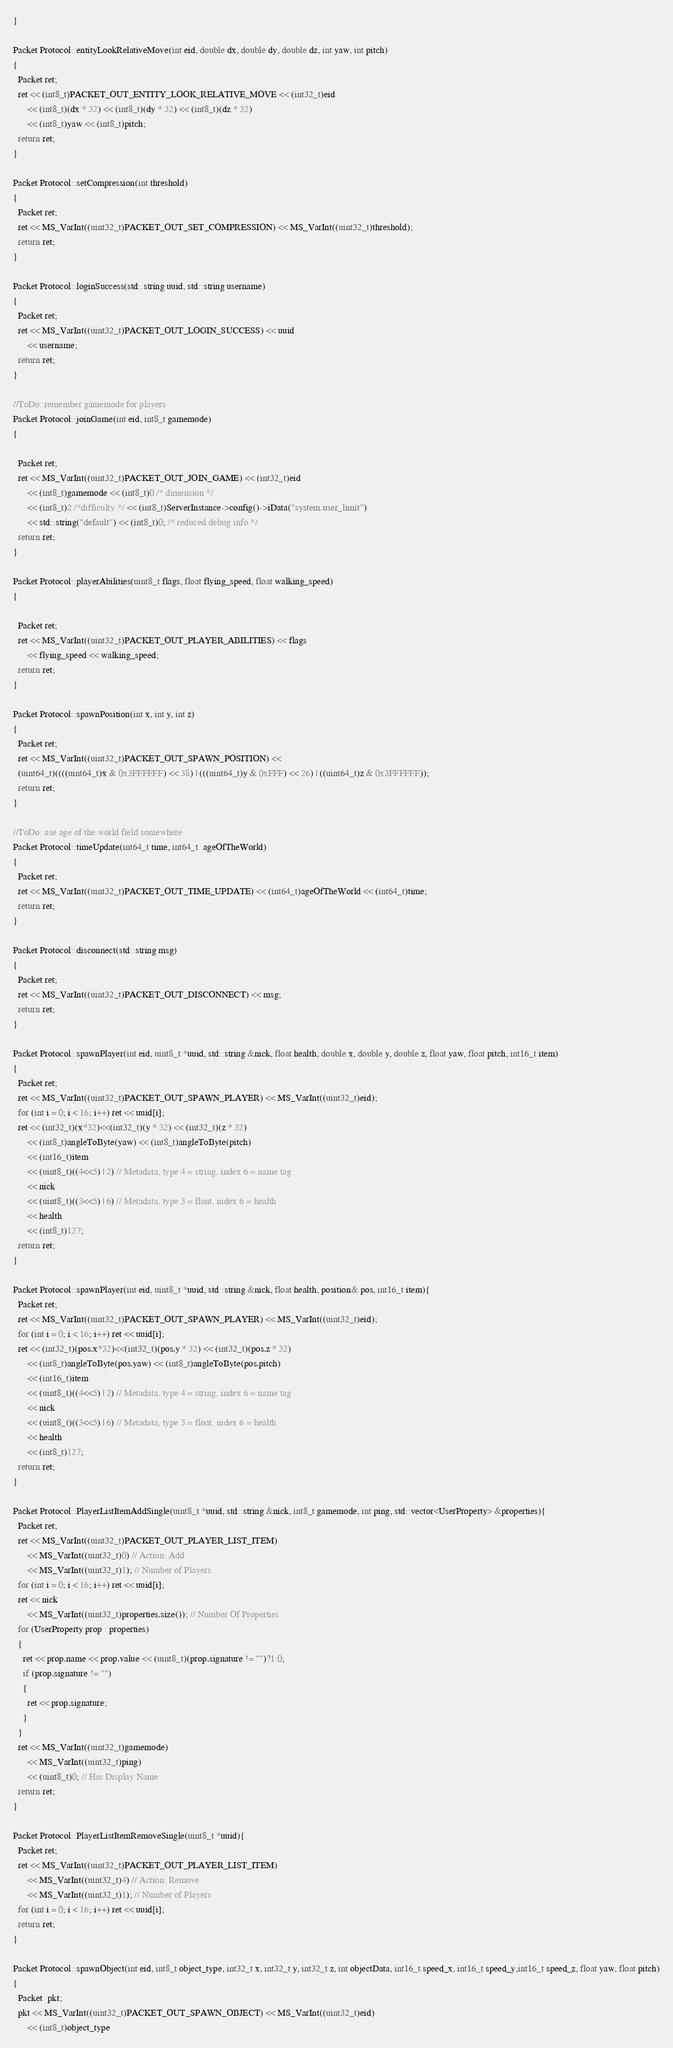Convert code to text. <code><loc_0><loc_0><loc_500><loc_500><_C++_>}
    
Packet Protocol::entityLookRelativeMove(int eid, double dx, double dy, double dz, int yaw, int pitch)
{
  Packet ret;
  ret << (int8_t)PACKET_OUT_ENTITY_LOOK_RELATIVE_MOVE << (int32_t)eid
      << (int8_t)(dx * 32) << (int8_t)(dy * 32) << (int8_t)(dz * 32)
      << (int8_t)yaw << (int8_t)pitch;
  return ret;
}

Packet Protocol::setCompression(int threshold)
{
  Packet ret;
  ret << MS_VarInt((uint32_t)PACKET_OUT_SET_COMPRESSION) << MS_VarInt((uint32_t)threshold);
  return ret;
}

Packet Protocol::loginSuccess(std::string uuid, std::string username)
{
  Packet ret;
  ret << MS_VarInt((uint32_t)PACKET_OUT_LOGIN_SUCCESS) << uuid
      << username;
  return ret;
}

//ToDo: remember gamemode for players
Packet Protocol::joinGame(int eid, int8_t gamemode)
{

  Packet ret;
  ret << MS_VarInt((uint32_t)PACKET_OUT_JOIN_GAME) << (int32_t)eid
      << (int8_t)gamemode << (int8_t)0 /* dimension */
      << (int8_t)2 /*difficulty */ << (int8_t)ServerInstance->config()->iData("system.user_limit")
      << std::string("default") << (int8_t)0; /* reduced debug info */
  return ret;
}

Packet Protocol::playerAbilities(uint8_t flags, float flying_speed, float walking_speed)
{

  Packet ret;
  ret << MS_VarInt((uint32_t)PACKET_OUT_PLAYER_ABILITIES) << flags
      << flying_speed << walking_speed;
  return ret;
}

Packet Protocol::spawnPosition(int x, int y, int z)
{
  Packet ret;
  ret << MS_VarInt((uint32_t)PACKET_OUT_SPAWN_POSITION) << 
  (uint64_t)((((uint64_t)x & 0x3FFFFFF) << 38) | (((uint64_t)y & 0xFFF) << 26) | ((uint64_t)z & 0x3FFFFFF));
  return ret;
}

//ToDo: use age of the world field somewhere
Packet Protocol::timeUpdate(int64_t time, int64_t  ageOfTheWorld)
{
  Packet ret;
  ret << MS_VarInt((uint32_t)PACKET_OUT_TIME_UPDATE) << (int64_t)ageOfTheWorld << (int64_t)time;
  return ret;
}

Packet Protocol::disconnect(std::string msg)
{
  Packet ret;
  ret << MS_VarInt((uint32_t)PACKET_OUT_DISCONNECT) << msg;
  return ret;
}

Packet Protocol::spawnPlayer(int eid, uint8_t *uuid, std::string &nick, float health, double x, double y, double z, float yaw, float pitch, int16_t item)
{
  Packet ret;
  ret << MS_VarInt((uint32_t)PACKET_OUT_SPAWN_PLAYER) << MS_VarInt((uint32_t)eid);
  for (int i = 0; i < 16; i++) ret << uuid[i];
  ret << (int32_t)(x*32)<<(int32_t)(y * 32) << (int32_t)(z * 32)
      << (int8_t)angleToByte(yaw) << (int8_t)angleToByte(pitch)
      << (int16_t)item
      << (uint8_t)((4<<5) | 2) // Metadata, type 4 = string, index 6 = name tag
      << nick
      << (uint8_t)((3<<5) | 6) // Metadata, type 3 = float, index 6 = health
      << health
      << (int8_t)127;
  return ret;
}

Packet Protocol::spawnPlayer(int eid, uint8_t *uuid, std::string &nick, float health, position& pos, int16_t item){
  Packet ret;
  ret << MS_VarInt((uint32_t)PACKET_OUT_SPAWN_PLAYER) << MS_VarInt((uint32_t)eid);
  for (int i = 0; i < 16; i++) ret << uuid[i];
  ret << (int32_t)(pos.x*32)<<(int32_t)(pos.y * 32) << (int32_t)(pos.z * 32)
      << (int8_t)angleToByte(pos.yaw) << (int8_t)angleToByte(pos.pitch)
      << (int16_t)item
      << (uint8_t)((4<<5) | 2) // Metadata, type 4 = string, index 6 = name tag
      << nick
      << (uint8_t)((3<<5) | 6) // Metadata, type 3 = float, index 6 = health
      << health
      << (int8_t)127;
  return ret;
}

Packet Protocol::PlayerListItemAddSingle(uint8_t *uuid, std::string &nick, int8_t gamemode, int ping, std::vector<UserProperty> &properties){
  Packet ret;
  ret << MS_VarInt((uint32_t)PACKET_OUT_PLAYER_LIST_ITEM) 
      << MS_VarInt((uint32_t)0) // Action: Add
      << MS_VarInt((uint32_t)1); // Number of Players
  for (int i = 0; i < 16; i++) ret << uuid[i];
  ret << nick
      << MS_VarInt((uint32_t)properties.size()); // Number Of Properties
  for (UserProperty prop : properties)
  {
    ret << prop.name << prop.value << (uint8_t)(prop.signature != "")?1:0;
    if (prop.signature != "")
    {
      ret << prop.signature;
    }
  }
  ret << MS_VarInt((uint32_t)gamemode)
      << MS_VarInt((uint32_t)ping)
      << (uint8_t)0; // Has Display Name
  return ret;
}

Packet Protocol::PlayerListItemRemoveSingle(uint8_t *uuid){
  Packet ret;
  ret << MS_VarInt((uint32_t)PACKET_OUT_PLAYER_LIST_ITEM) 
      << MS_VarInt((uint32_t)4) // Action: Remove
      << MS_VarInt((uint32_t)1); // Number of Players
  for (int i = 0; i < 16; i++) ret << uuid[i];
  return ret;
}

Packet Protocol::spawnObject(int eid, int8_t object_type, int32_t x, int32_t y, int32_t z, int objectData, int16_t speed_x, int16_t speed_y,int16_t speed_z, float yaw, float pitch)
{
  Packet  pkt; 
  pkt << MS_VarInt((uint32_t)PACKET_OUT_SPAWN_OBJECT) << MS_VarInt((uint32_t)eid)
      << (int8_t)object_type</code> 